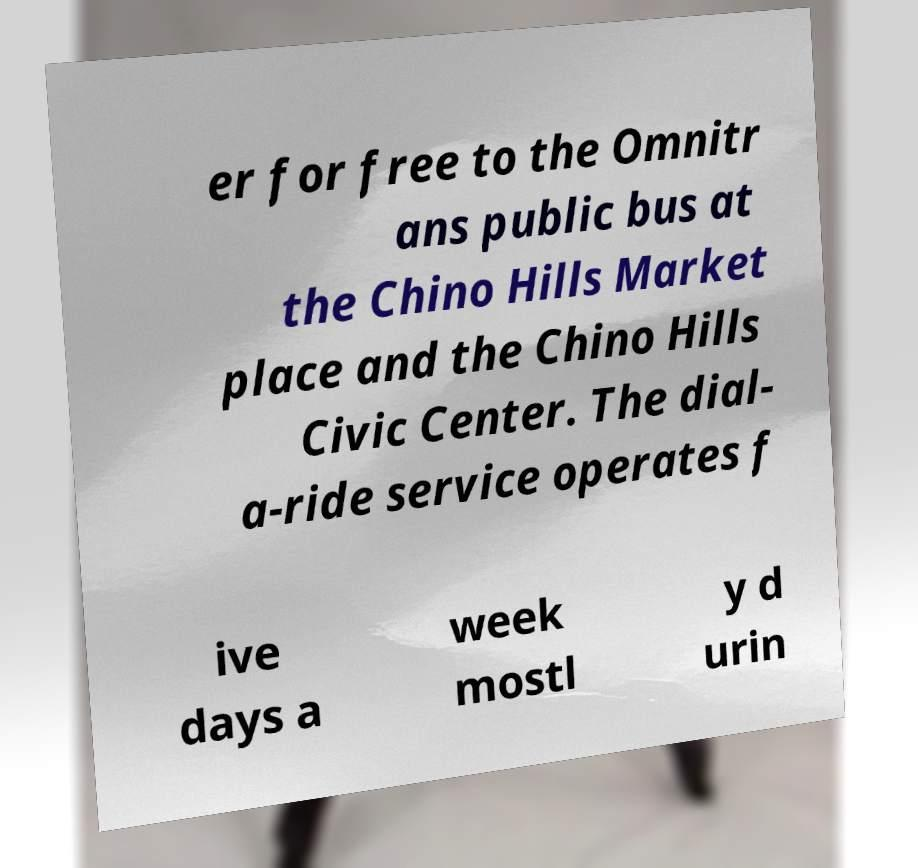For documentation purposes, I need the text within this image transcribed. Could you provide that? er for free to the Omnitr ans public bus at the Chino Hills Market place and the Chino Hills Civic Center. The dial- a-ride service operates f ive days a week mostl y d urin 